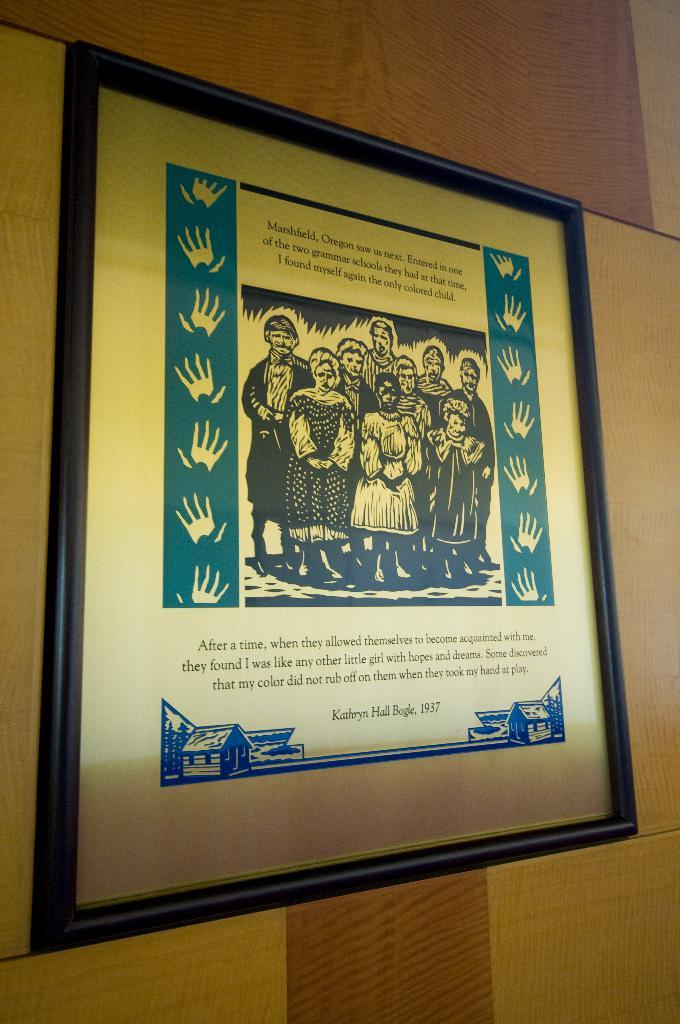<image>
Describe the image concisely. A framed drawing of people including Kathryn Hail Beagle from 1937. 